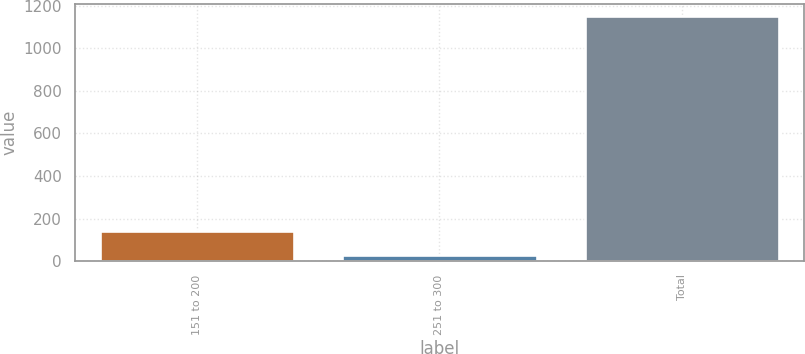Convert chart to OTSL. <chart><loc_0><loc_0><loc_500><loc_500><bar_chart><fcel>151 to 200<fcel>251 to 300<fcel>Total<nl><fcel>139.45<fcel>27<fcel>1151.5<nl></chart> 